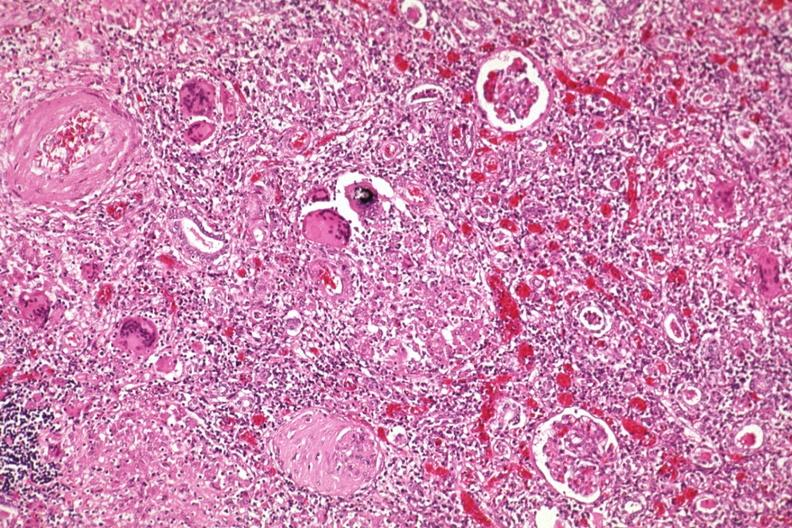s kidney present?
Answer the question using a single word or phrase. Yes 